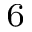<formula> <loc_0><loc_0><loc_500><loc_500>_ { 6 }</formula> 